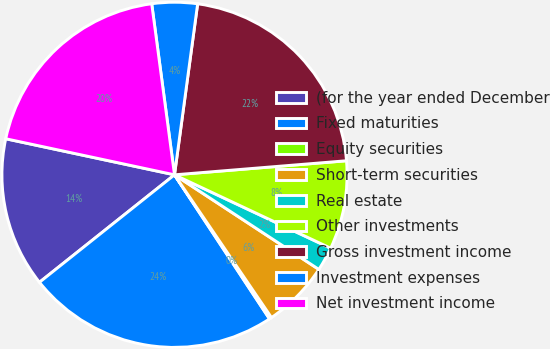Convert chart. <chart><loc_0><loc_0><loc_500><loc_500><pie_chart><fcel>(for the year ended December<fcel>Fixed maturities<fcel>Equity securities<fcel>Short-term securities<fcel>Real estate<fcel>Other investments<fcel>Gross investment income<fcel>Investment expenses<fcel>Net investment income<nl><fcel>14.05%<fcel>23.58%<fcel>0.22%<fcel>6.27%<fcel>2.24%<fcel>8.29%<fcel>21.56%<fcel>4.25%<fcel>19.54%<nl></chart> 